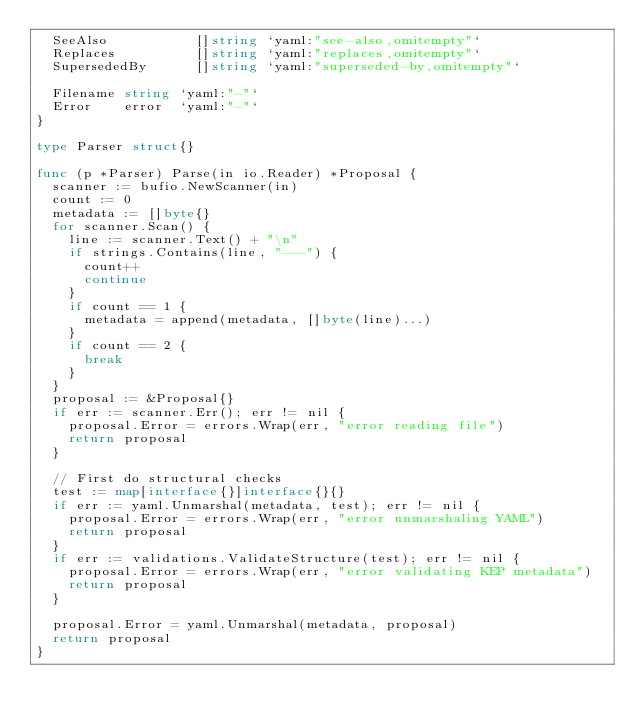<code> <loc_0><loc_0><loc_500><loc_500><_Go_>	SeeAlso           []string `yaml:"see-also,omitempty"`
	Replaces          []string `yaml:"replaces,omitempty"`
	SupersededBy      []string `yaml:"superseded-by,omitempty"`

	Filename string `yaml:"-"`
	Error    error  `yaml:"-"`
}

type Parser struct{}

func (p *Parser) Parse(in io.Reader) *Proposal {
	scanner := bufio.NewScanner(in)
	count := 0
	metadata := []byte{}
	for scanner.Scan() {
		line := scanner.Text() + "\n"
		if strings.Contains(line, "---") {
			count++
			continue
		}
		if count == 1 {
			metadata = append(metadata, []byte(line)...)
		}
		if count == 2 {
			break
		}
	}
	proposal := &Proposal{}
	if err := scanner.Err(); err != nil {
		proposal.Error = errors.Wrap(err, "error reading file")
		return proposal
	}

	// First do structural checks
	test := map[interface{}]interface{}{}
	if err := yaml.Unmarshal(metadata, test); err != nil {
		proposal.Error = errors.Wrap(err, "error unmarshaling YAML")
		return proposal
	}
	if err := validations.ValidateStructure(test); err != nil {
		proposal.Error = errors.Wrap(err, "error validating KEP metadata")
		return proposal
	}

	proposal.Error = yaml.Unmarshal(metadata, proposal)
	return proposal
}
</code> 